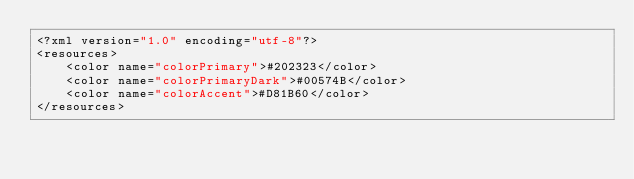Convert code to text. <code><loc_0><loc_0><loc_500><loc_500><_XML_><?xml version="1.0" encoding="utf-8"?>
<resources>
    <color name="colorPrimary">#202323</color>
    <color name="colorPrimaryDark">#00574B</color>
    <color name="colorAccent">#D81B60</color>
</resources>
</code> 